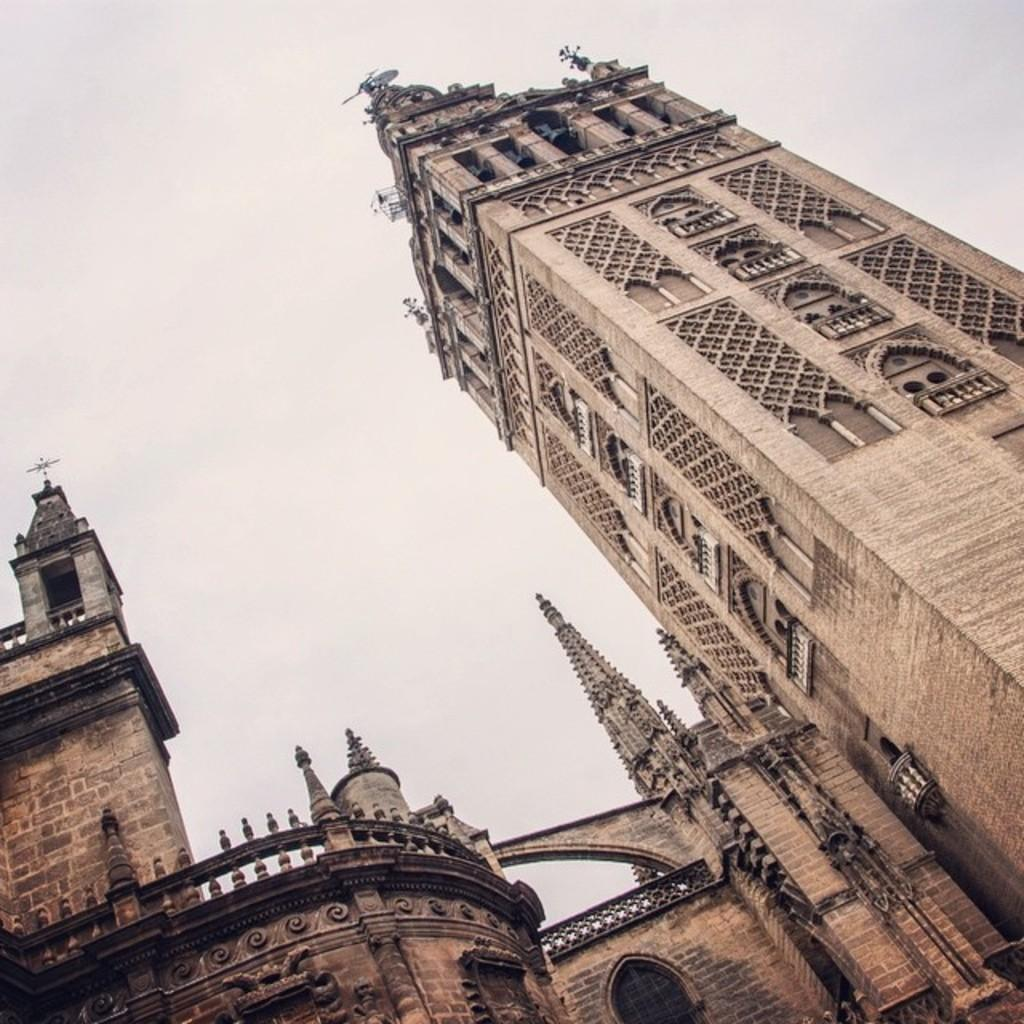What is the main subject in the center of the image? There is a church in the center of the image. Are there any cherries hanging from the church in the image? There are no cherries present in the image, and therefore no such activity can be observed. 